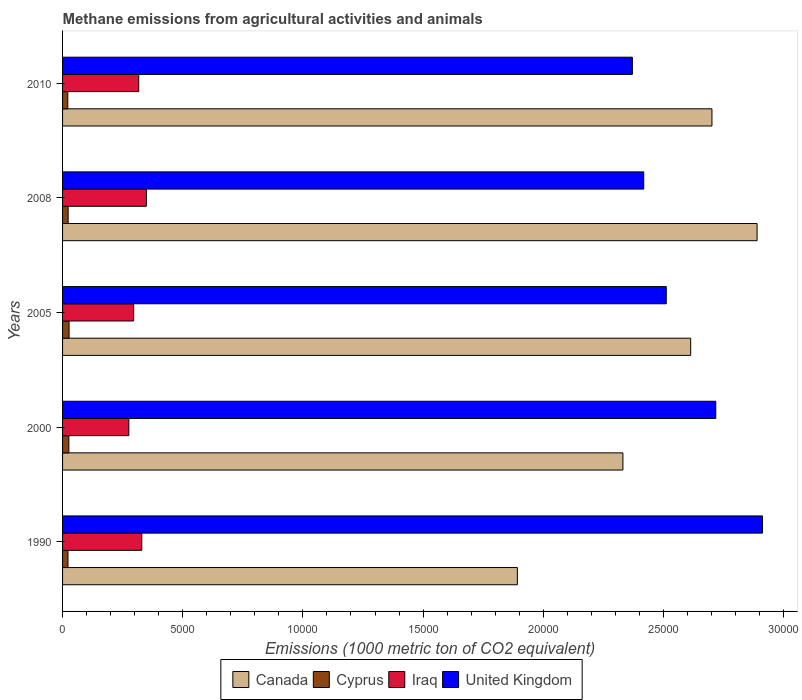How many different coloured bars are there?
Give a very brief answer. 4. How many bars are there on the 3rd tick from the top?
Give a very brief answer. 4. What is the label of the 4th group of bars from the top?
Offer a terse response. 2000. In how many cases, is the number of bars for a given year not equal to the number of legend labels?
Provide a short and direct response. 0. What is the amount of methane emitted in Canada in 2000?
Give a very brief answer. 2.33e+04. Across all years, what is the maximum amount of methane emitted in Iraq?
Your answer should be compact. 3487.5. Across all years, what is the minimum amount of methane emitted in United Kingdom?
Your answer should be compact. 2.37e+04. In which year was the amount of methane emitted in United Kingdom maximum?
Give a very brief answer. 1990. What is the total amount of methane emitted in Canada in the graph?
Offer a very short reply. 1.24e+05. What is the difference between the amount of methane emitted in Cyprus in 2000 and that in 2010?
Your answer should be very brief. 44.1. What is the difference between the amount of methane emitted in United Kingdom in 1990 and the amount of methane emitted in Cyprus in 2010?
Your answer should be very brief. 2.89e+04. What is the average amount of methane emitted in Cyprus per year?
Keep it short and to the point. 241.42. In the year 2005, what is the difference between the amount of methane emitted in Iraq and amount of methane emitted in United Kingdom?
Your response must be concise. -2.22e+04. In how many years, is the amount of methane emitted in Iraq greater than 15000 1000 metric ton?
Keep it short and to the point. 0. What is the ratio of the amount of methane emitted in Cyprus in 1990 to that in 2000?
Your answer should be very brief. 0.86. Is the amount of methane emitted in United Kingdom in 1990 less than that in 2008?
Ensure brevity in your answer.  No. Is the difference between the amount of methane emitted in Iraq in 1990 and 2010 greater than the difference between the amount of methane emitted in United Kingdom in 1990 and 2010?
Keep it short and to the point. No. What is the difference between the highest and the second highest amount of methane emitted in United Kingdom?
Your answer should be compact. 1944.1. What is the difference between the highest and the lowest amount of methane emitted in Iraq?
Keep it short and to the point. 731.3. Is it the case that in every year, the sum of the amount of methane emitted in Cyprus and amount of methane emitted in Canada is greater than the sum of amount of methane emitted in United Kingdom and amount of methane emitted in Iraq?
Keep it short and to the point. No. What does the 3rd bar from the bottom in 2010 represents?
Keep it short and to the point. Iraq. Are all the bars in the graph horizontal?
Ensure brevity in your answer.  Yes. How many years are there in the graph?
Give a very brief answer. 5. What is the difference between two consecutive major ticks on the X-axis?
Your answer should be very brief. 5000. Are the values on the major ticks of X-axis written in scientific E-notation?
Your answer should be compact. No. Does the graph contain any zero values?
Provide a succinct answer. No. Does the graph contain grids?
Keep it short and to the point. No. How many legend labels are there?
Offer a very short reply. 4. What is the title of the graph?
Keep it short and to the point. Methane emissions from agricultural activities and animals. What is the label or title of the X-axis?
Make the answer very short. Emissions (1000 metric ton of CO2 equivalent). What is the label or title of the Y-axis?
Your answer should be very brief. Years. What is the Emissions (1000 metric ton of CO2 equivalent) in Canada in 1990?
Provide a short and direct response. 1.89e+04. What is the Emissions (1000 metric ton of CO2 equivalent) in Cyprus in 1990?
Keep it short and to the point. 225.1. What is the Emissions (1000 metric ton of CO2 equivalent) in Iraq in 1990?
Ensure brevity in your answer.  3295.9. What is the Emissions (1000 metric ton of CO2 equivalent) in United Kingdom in 1990?
Make the answer very short. 2.91e+04. What is the Emissions (1000 metric ton of CO2 equivalent) of Canada in 2000?
Offer a terse response. 2.33e+04. What is the Emissions (1000 metric ton of CO2 equivalent) of Cyprus in 2000?
Provide a short and direct response. 261.7. What is the Emissions (1000 metric ton of CO2 equivalent) of Iraq in 2000?
Give a very brief answer. 2756.2. What is the Emissions (1000 metric ton of CO2 equivalent) of United Kingdom in 2000?
Provide a short and direct response. 2.72e+04. What is the Emissions (1000 metric ton of CO2 equivalent) in Canada in 2005?
Offer a very short reply. 2.61e+04. What is the Emissions (1000 metric ton of CO2 equivalent) of Cyprus in 2005?
Provide a short and direct response. 271. What is the Emissions (1000 metric ton of CO2 equivalent) of Iraq in 2005?
Provide a succinct answer. 2958.3. What is the Emissions (1000 metric ton of CO2 equivalent) of United Kingdom in 2005?
Offer a terse response. 2.51e+04. What is the Emissions (1000 metric ton of CO2 equivalent) in Canada in 2008?
Offer a terse response. 2.89e+04. What is the Emissions (1000 metric ton of CO2 equivalent) in Cyprus in 2008?
Offer a very short reply. 231.7. What is the Emissions (1000 metric ton of CO2 equivalent) of Iraq in 2008?
Provide a succinct answer. 3487.5. What is the Emissions (1000 metric ton of CO2 equivalent) in United Kingdom in 2008?
Give a very brief answer. 2.42e+04. What is the Emissions (1000 metric ton of CO2 equivalent) of Canada in 2010?
Offer a terse response. 2.70e+04. What is the Emissions (1000 metric ton of CO2 equivalent) of Cyprus in 2010?
Ensure brevity in your answer.  217.6. What is the Emissions (1000 metric ton of CO2 equivalent) of Iraq in 2010?
Provide a short and direct response. 3168.9. What is the Emissions (1000 metric ton of CO2 equivalent) of United Kingdom in 2010?
Ensure brevity in your answer.  2.37e+04. Across all years, what is the maximum Emissions (1000 metric ton of CO2 equivalent) in Canada?
Provide a short and direct response. 2.89e+04. Across all years, what is the maximum Emissions (1000 metric ton of CO2 equivalent) of Cyprus?
Your response must be concise. 271. Across all years, what is the maximum Emissions (1000 metric ton of CO2 equivalent) of Iraq?
Provide a succinct answer. 3487.5. Across all years, what is the maximum Emissions (1000 metric ton of CO2 equivalent) of United Kingdom?
Keep it short and to the point. 2.91e+04. Across all years, what is the minimum Emissions (1000 metric ton of CO2 equivalent) of Canada?
Offer a very short reply. 1.89e+04. Across all years, what is the minimum Emissions (1000 metric ton of CO2 equivalent) of Cyprus?
Your answer should be very brief. 217.6. Across all years, what is the minimum Emissions (1000 metric ton of CO2 equivalent) in Iraq?
Your response must be concise. 2756.2. Across all years, what is the minimum Emissions (1000 metric ton of CO2 equivalent) in United Kingdom?
Offer a terse response. 2.37e+04. What is the total Emissions (1000 metric ton of CO2 equivalent) in Canada in the graph?
Give a very brief answer. 1.24e+05. What is the total Emissions (1000 metric ton of CO2 equivalent) in Cyprus in the graph?
Your response must be concise. 1207.1. What is the total Emissions (1000 metric ton of CO2 equivalent) of Iraq in the graph?
Your answer should be very brief. 1.57e+04. What is the total Emissions (1000 metric ton of CO2 equivalent) in United Kingdom in the graph?
Offer a terse response. 1.29e+05. What is the difference between the Emissions (1000 metric ton of CO2 equivalent) of Canada in 1990 and that in 2000?
Ensure brevity in your answer.  -4391.7. What is the difference between the Emissions (1000 metric ton of CO2 equivalent) of Cyprus in 1990 and that in 2000?
Offer a terse response. -36.6. What is the difference between the Emissions (1000 metric ton of CO2 equivalent) of Iraq in 1990 and that in 2000?
Your answer should be very brief. 539.7. What is the difference between the Emissions (1000 metric ton of CO2 equivalent) of United Kingdom in 1990 and that in 2000?
Offer a terse response. 1944.1. What is the difference between the Emissions (1000 metric ton of CO2 equivalent) in Canada in 1990 and that in 2005?
Your answer should be very brief. -7210.8. What is the difference between the Emissions (1000 metric ton of CO2 equivalent) in Cyprus in 1990 and that in 2005?
Give a very brief answer. -45.9. What is the difference between the Emissions (1000 metric ton of CO2 equivalent) of Iraq in 1990 and that in 2005?
Make the answer very short. 337.6. What is the difference between the Emissions (1000 metric ton of CO2 equivalent) of United Kingdom in 1990 and that in 2005?
Provide a succinct answer. 4004.1. What is the difference between the Emissions (1000 metric ton of CO2 equivalent) of Canada in 1990 and that in 2008?
Your answer should be very brief. -9973.1. What is the difference between the Emissions (1000 metric ton of CO2 equivalent) of Iraq in 1990 and that in 2008?
Your answer should be compact. -191.6. What is the difference between the Emissions (1000 metric ton of CO2 equivalent) in United Kingdom in 1990 and that in 2008?
Provide a succinct answer. 4941.2. What is the difference between the Emissions (1000 metric ton of CO2 equivalent) of Canada in 1990 and that in 2010?
Offer a terse response. -8095.8. What is the difference between the Emissions (1000 metric ton of CO2 equivalent) in Cyprus in 1990 and that in 2010?
Your answer should be compact. 7.5. What is the difference between the Emissions (1000 metric ton of CO2 equivalent) in Iraq in 1990 and that in 2010?
Provide a short and direct response. 127. What is the difference between the Emissions (1000 metric ton of CO2 equivalent) of United Kingdom in 1990 and that in 2010?
Your response must be concise. 5414.5. What is the difference between the Emissions (1000 metric ton of CO2 equivalent) in Canada in 2000 and that in 2005?
Ensure brevity in your answer.  -2819.1. What is the difference between the Emissions (1000 metric ton of CO2 equivalent) of Cyprus in 2000 and that in 2005?
Your answer should be compact. -9.3. What is the difference between the Emissions (1000 metric ton of CO2 equivalent) of Iraq in 2000 and that in 2005?
Your response must be concise. -202.1. What is the difference between the Emissions (1000 metric ton of CO2 equivalent) in United Kingdom in 2000 and that in 2005?
Provide a succinct answer. 2060. What is the difference between the Emissions (1000 metric ton of CO2 equivalent) of Canada in 2000 and that in 2008?
Provide a succinct answer. -5581.4. What is the difference between the Emissions (1000 metric ton of CO2 equivalent) of Cyprus in 2000 and that in 2008?
Make the answer very short. 30. What is the difference between the Emissions (1000 metric ton of CO2 equivalent) of Iraq in 2000 and that in 2008?
Give a very brief answer. -731.3. What is the difference between the Emissions (1000 metric ton of CO2 equivalent) of United Kingdom in 2000 and that in 2008?
Ensure brevity in your answer.  2997.1. What is the difference between the Emissions (1000 metric ton of CO2 equivalent) of Canada in 2000 and that in 2010?
Ensure brevity in your answer.  -3704.1. What is the difference between the Emissions (1000 metric ton of CO2 equivalent) in Cyprus in 2000 and that in 2010?
Offer a very short reply. 44.1. What is the difference between the Emissions (1000 metric ton of CO2 equivalent) in Iraq in 2000 and that in 2010?
Provide a short and direct response. -412.7. What is the difference between the Emissions (1000 metric ton of CO2 equivalent) in United Kingdom in 2000 and that in 2010?
Keep it short and to the point. 3470.4. What is the difference between the Emissions (1000 metric ton of CO2 equivalent) in Canada in 2005 and that in 2008?
Give a very brief answer. -2762.3. What is the difference between the Emissions (1000 metric ton of CO2 equivalent) in Cyprus in 2005 and that in 2008?
Ensure brevity in your answer.  39.3. What is the difference between the Emissions (1000 metric ton of CO2 equivalent) in Iraq in 2005 and that in 2008?
Give a very brief answer. -529.2. What is the difference between the Emissions (1000 metric ton of CO2 equivalent) in United Kingdom in 2005 and that in 2008?
Make the answer very short. 937.1. What is the difference between the Emissions (1000 metric ton of CO2 equivalent) of Canada in 2005 and that in 2010?
Ensure brevity in your answer.  -885. What is the difference between the Emissions (1000 metric ton of CO2 equivalent) of Cyprus in 2005 and that in 2010?
Offer a very short reply. 53.4. What is the difference between the Emissions (1000 metric ton of CO2 equivalent) of Iraq in 2005 and that in 2010?
Keep it short and to the point. -210.6. What is the difference between the Emissions (1000 metric ton of CO2 equivalent) of United Kingdom in 2005 and that in 2010?
Provide a succinct answer. 1410.4. What is the difference between the Emissions (1000 metric ton of CO2 equivalent) in Canada in 2008 and that in 2010?
Offer a very short reply. 1877.3. What is the difference between the Emissions (1000 metric ton of CO2 equivalent) of Cyprus in 2008 and that in 2010?
Your answer should be very brief. 14.1. What is the difference between the Emissions (1000 metric ton of CO2 equivalent) in Iraq in 2008 and that in 2010?
Your answer should be compact. 318.6. What is the difference between the Emissions (1000 metric ton of CO2 equivalent) of United Kingdom in 2008 and that in 2010?
Your response must be concise. 473.3. What is the difference between the Emissions (1000 metric ton of CO2 equivalent) of Canada in 1990 and the Emissions (1000 metric ton of CO2 equivalent) of Cyprus in 2000?
Ensure brevity in your answer.  1.87e+04. What is the difference between the Emissions (1000 metric ton of CO2 equivalent) of Canada in 1990 and the Emissions (1000 metric ton of CO2 equivalent) of Iraq in 2000?
Ensure brevity in your answer.  1.62e+04. What is the difference between the Emissions (1000 metric ton of CO2 equivalent) of Canada in 1990 and the Emissions (1000 metric ton of CO2 equivalent) of United Kingdom in 2000?
Ensure brevity in your answer.  -8254.7. What is the difference between the Emissions (1000 metric ton of CO2 equivalent) in Cyprus in 1990 and the Emissions (1000 metric ton of CO2 equivalent) in Iraq in 2000?
Your response must be concise. -2531.1. What is the difference between the Emissions (1000 metric ton of CO2 equivalent) in Cyprus in 1990 and the Emissions (1000 metric ton of CO2 equivalent) in United Kingdom in 2000?
Provide a succinct answer. -2.70e+04. What is the difference between the Emissions (1000 metric ton of CO2 equivalent) of Iraq in 1990 and the Emissions (1000 metric ton of CO2 equivalent) of United Kingdom in 2000?
Your answer should be very brief. -2.39e+04. What is the difference between the Emissions (1000 metric ton of CO2 equivalent) in Canada in 1990 and the Emissions (1000 metric ton of CO2 equivalent) in Cyprus in 2005?
Provide a succinct answer. 1.87e+04. What is the difference between the Emissions (1000 metric ton of CO2 equivalent) of Canada in 1990 and the Emissions (1000 metric ton of CO2 equivalent) of Iraq in 2005?
Offer a very short reply. 1.60e+04. What is the difference between the Emissions (1000 metric ton of CO2 equivalent) of Canada in 1990 and the Emissions (1000 metric ton of CO2 equivalent) of United Kingdom in 2005?
Keep it short and to the point. -6194.7. What is the difference between the Emissions (1000 metric ton of CO2 equivalent) of Cyprus in 1990 and the Emissions (1000 metric ton of CO2 equivalent) of Iraq in 2005?
Provide a short and direct response. -2733.2. What is the difference between the Emissions (1000 metric ton of CO2 equivalent) of Cyprus in 1990 and the Emissions (1000 metric ton of CO2 equivalent) of United Kingdom in 2005?
Offer a terse response. -2.49e+04. What is the difference between the Emissions (1000 metric ton of CO2 equivalent) of Iraq in 1990 and the Emissions (1000 metric ton of CO2 equivalent) of United Kingdom in 2005?
Keep it short and to the point. -2.18e+04. What is the difference between the Emissions (1000 metric ton of CO2 equivalent) in Canada in 1990 and the Emissions (1000 metric ton of CO2 equivalent) in Cyprus in 2008?
Ensure brevity in your answer.  1.87e+04. What is the difference between the Emissions (1000 metric ton of CO2 equivalent) of Canada in 1990 and the Emissions (1000 metric ton of CO2 equivalent) of Iraq in 2008?
Offer a terse response. 1.54e+04. What is the difference between the Emissions (1000 metric ton of CO2 equivalent) in Canada in 1990 and the Emissions (1000 metric ton of CO2 equivalent) in United Kingdom in 2008?
Offer a terse response. -5257.6. What is the difference between the Emissions (1000 metric ton of CO2 equivalent) of Cyprus in 1990 and the Emissions (1000 metric ton of CO2 equivalent) of Iraq in 2008?
Your response must be concise. -3262.4. What is the difference between the Emissions (1000 metric ton of CO2 equivalent) in Cyprus in 1990 and the Emissions (1000 metric ton of CO2 equivalent) in United Kingdom in 2008?
Your answer should be very brief. -2.40e+04. What is the difference between the Emissions (1000 metric ton of CO2 equivalent) of Iraq in 1990 and the Emissions (1000 metric ton of CO2 equivalent) of United Kingdom in 2008?
Give a very brief answer. -2.09e+04. What is the difference between the Emissions (1000 metric ton of CO2 equivalent) of Canada in 1990 and the Emissions (1000 metric ton of CO2 equivalent) of Cyprus in 2010?
Your answer should be compact. 1.87e+04. What is the difference between the Emissions (1000 metric ton of CO2 equivalent) in Canada in 1990 and the Emissions (1000 metric ton of CO2 equivalent) in Iraq in 2010?
Your answer should be compact. 1.58e+04. What is the difference between the Emissions (1000 metric ton of CO2 equivalent) in Canada in 1990 and the Emissions (1000 metric ton of CO2 equivalent) in United Kingdom in 2010?
Provide a succinct answer. -4784.3. What is the difference between the Emissions (1000 metric ton of CO2 equivalent) in Cyprus in 1990 and the Emissions (1000 metric ton of CO2 equivalent) in Iraq in 2010?
Provide a short and direct response. -2943.8. What is the difference between the Emissions (1000 metric ton of CO2 equivalent) in Cyprus in 1990 and the Emissions (1000 metric ton of CO2 equivalent) in United Kingdom in 2010?
Your answer should be very brief. -2.35e+04. What is the difference between the Emissions (1000 metric ton of CO2 equivalent) in Iraq in 1990 and the Emissions (1000 metric ton of CO2 equivalent) in United Kingdom in 2010?
Give a very brief answer. -2.04e+04. What is the difference between the Emissions (1000 metric ton of CO2 equivalent) in Canada in 2000 and the Emissions (1000 metric ton of CO2 equivalent) in Cyprus in 2005?
Ensure brevity in your answer.  2.30e+04. What is the difference between the Emissions (1000 metric ton of CO2 equivalent) in Canada in 2000 and the Emissions (1000 metric ton of CO2 equivalent) in Iraq in 2005?
Give a very brief answer. 2.04e+04. What is the difference between the Emissions (1000 metric ton of CO2 equivalent) in Canada in 2000 and the Emissions (1000 metric ton of CO2 equivalent) in United Kingdom in 2005?
Ensure brevity in your answer.  -1803. What is the difference between the Emissions (1000 metric ton of CO2 equivalent) in Cyprus in 2000 and the Emissions (1000 metric ton of CO2 equivalent) in Iraq in 2005?
Keep it short and to the point. -2696.6. What is the difference between the Emissions (1000 metric ton of CO2 equivalent) of Cyprus in 2000 and the Emissions (1000 metric ton of CO2 equivalent) of United Kingdom in 2005?
Provide a succinct answer. -2.49e+04. What is the difference between the Emissions (1000 metric ton of CO2 equivalent) in Iraq in 2000 and the Emissions (1000 metric ton of CO2 equivalent) in United Kingdom in 2005?
Offer a very short reply. -2.24e+04. What is the difference between the Emissions (1000 metric ton of CO2 equivalent) in Canada in 2000 and the Emissions (1000 metric ton of CO2 equivalent) in Cyprus in 2008?
Ensure brevity in your answer.  2.31e+04. What is the difference between the Emissions (1000 metric ton of CO2 equivalent) of Canada in 2000 and the Emissions (1000 metric ton of CO2 equivalent) of Iraq in 2008?
Offer a very short reply. 1.98e+04. What is the difference between the Emissions (1000 metric ton of CO2 equivalent) of Canada in 2000 and the Emissions (1000 metric ton of CO2 equivalent) of United Kingdom in 2008?
Make the answer very short. -865.9. What is the difference between the Emissions (1000 metric ton of CO2 equivalent) in Cyprus in 2000 and the Emissions (1000 metric ton of CO2 equivalent) in Iraq in 2008?
Your answer should be very brief. -3225.8. What is the difference between the Emissions (1000 metric ton of CO2 equivalent) in Cyprus in 2000 and the Emissions (1000 metric ton of CO2 equivalent) in United Kingdom in 2008?
Your answer should be compact. -2.39e+04. What is the difference between the Emissions (1000 metric ton of CO2 equivalent) of Iraq in 2000 and the Emissions (1000 metric ton of CO2 equivalent) of United Kingdom in 2008?
Ensure brevity in your answer.  -2.14e+04. What is the difference between the Emissions (1000 metric ton of CO2 equivalent) of Canada in 2000 and the Emissions (1000 metric ton of CO2 equivalent) of Cyprus in 2010?
Keep it short and to the point. 2.31e+04. What is the difference between the Emissions (1000 metric ton of CO2 equivalent) in Canada in 2000 and the Emissions (1000 metric ton of CO2 equivalent) in Iraq in 2010?
Provide a short and direct response. 2.01e+04. What is the difference between the Emissions (1000 metric ton of CO2 equivalent) of Canada in 2000 and the Emissions (1000 metric ton of CO2 equivalent) of United Kingdom in 2010?
Ensure brevity in your answer.  -392.6. What is the difference between the Emissions (1000 metric ton of CO2 equivalent) in Cyprus in 2000 and the Emissions (1000 metric ton of CO2 equivalent) in Iraq in 2010?
Make the answer very short. -2907.2. What is the difference between the Emissions (1000 metric ton of CO2 equivalent) of Cyprus in 2000 and the Emissions (1000 metric ton of CO2 equivalent) of United Kingdom in 2010?
Ensure brevity in your answer.  -2.34e+04. What is the difference between the Emissions (1000 metric ton of CO2 equivalent) in Iraq in 2000 and the Emissions (1000 metric ton of CO2 equivalent) in United Kingdom in 2010?
Provide a short and direct response. -2.10e+04. What is the difference between the Emissions (1000 metric ton of CO2 equivalent) of Canada in 2005 and the Emissions (1000 metric ton of CO2 equivalent) of Cyprus in 2008?
Your answer should be very brief. 2.59e+04. What is the difference between the Emissions (1000 metric ton of CO2 equivalent) in Canada in 2005 and the Emissions (1000 metric ton of CO2 equivalent) in Iraq in 2008?
Keep it short and to the point. 2.26e+04. What is the difference between the Emissions (1000 metric ton of CO2 equivalent) of Canada in 2005 and the Emissions (1000 metric ton of CO2 equivalent) of United Kingdom in 2008?
Give a very brief answer. 1953.2. What is the difference between the Emissions (1000 metric ton of CO2 equivalent) of Cyprus in 2005 and the Emissions (1000 metric ton of CO2 equivalent) of Iraq in 2008?
Give a very brief answer. -3216.5. What is the difference between the Emissions (1000 metric ton of CO2 equivalent) of Cyprus in 2005 and the Emissions (1000 metric ton of CO2 equivalent) of United Kingdom in 2008?
Keep it short and to the point. -2.39e+04. What is the difference between the Emissions (1000 metric ton of CO2 equivalent) in Iraq in 2005 and the Emissions (1000 metric ton of CO2 equivalent) in United Kingdom in 2008?
Your answer should be very brief. -2.12e+04. What is the difference between the Emissions (1000 metric ton of CO2 equivalent) of Canada in 2005 and the Emissions (1000 metric ton of CO2 equivalent) of Cyprus in 2010?
Provide a short and direct response. 2.59e+04. What is the difference between the Emissions (1000 metric ton of CO2 equivalent) of Canada in 2005 and the Emissions (1000 metric ton of CO2 equivalent) of Iraq in 2010?
Your answer should be very brief. 2.30e+04. What is the difference between the Emissions (1000 metric ton of CO2 equivalent) of Canada in 2005 and the Emissions (1000 metric ton of CO2 equivalent) of United Kingdom in 2010?
Ensure brevity in your answer.  2426.5. What is the difference between the Emissions (1000 metric ton of CO2 equivalent) in Cyprus in 2005 and the Emissions (1000 metric ton of CO2 equivalent) in Iraq in 2010?
Your answer should be compact. -2897.9. What is the difference between the Emissions (1000 metric ton of CO2 equivalent) of Cyprus in 2005 and the Emissions (1000 metric ton of CO2 equivalent) of United Kingdom in 2010?
Ensure brevity in your answer.  -2.34e+04. What is the difference between the Emissions (1000 metric ton of CO2 equivalent) of Iraq in 2005 and the Emissions (1000 metric ton of CO2 equivalent) of United Kingdom in 2010?
Provide a succinct answer. -2.07e+04. What is the difference between the Emissions (1000 metric ton of CO2 equivalent) in Canada in 2008 and the Emissions (1000 metric ton of CO2 equivalent) in Cyprus in 2010?
Ensure brevity in your answer.  2.87e+04. What is the difference between the Emissions (1000 metric ton of CO2 equivalent) of Canada in 2008 and the Emissions (1000 metric ton of CO2 equivalent) of Iraq in 2010?
Provide a short and direct response. 2.57e+04. What is the difference between the Emissions (1000 metric ton of CO2 equivalent) in Canada in 2008 and the Emissions (1000 metric ton of CO2 equivalent) in United Kingdom in 2010?
Offer a terse response. 5188.8. What is the difference between the Emissions (1000 metric ton of CO2 equivalent) in Cyprus in 2008 and the Emissions (1000 metric ton of CO2 equivalent) in Iraq in 2010?
Your answer should be compact. -2937.2. What is the difference between the Emissions (1000 metric ton of CO2 equivalent) of Cyprus in 2008 and the Emissions (1000 metric ton of CO2 equivalent) of United Kingdom in 2010?
Provide a short and direct response. -2.35e+04. What is the difference between the Emissions (1000 metric ton of CO2 equivalent) in Iraq in 2008 and the Emissions (1000 metric ton of CO2 equivalent) in United Kingdom in 2010?
Your answer should be very brief. -2.02e+04. What is the average Emissions (1000 metric ton of CO2 equivalent) in Canada per year?
Your response must be concise. 2.49e+04. What is the average Emissions (1000 metric ton of CO2 equivalent) of Cyprus per year?
Give a very brief answer. 241.42. What is the average Emissions (1000 metric ton of CO2 equivalent) of Iraq per year?
Your answer should be compact. 3133.36. What is the average Emissions (1000 metric ton of CO2 equivalent) of United Kingdom per year?
Ensure brevity in your answer.  2.59e+04. In the year 1990, what is the difference between the Emissions (1000 metric ton of CO2 equivalent) of Canada and Emissions (1000 metric ton of CO2 equivalent) of Cyprus?
Provide a succinct answer. 1.87e+04. In the year 1990, what is the difference between the Emissions (1000 metric ton of CO2 equivalent) in Canada and Emissions (1000 metric ton of CO2 equivalent) in Iraq?
Ensure brevity in your answer.  1.56e+04. In the year 1990, what is the difference between the Emissions (1000 metric ton of CO2 equivalent) of Canada and Emissions (1000 metric ton of CO2 equivalent) of United Kingdom?
Provide a short and direct response. -1.02e+04. In the year 1990, what is the difference between the Emissions (1000 metric ton of CO2 equivalent) of Cyprus and Emissions (1000 metric ton of CO2 equivalent) of Iraq?
Your response must be concise. -3070.8. In the year 1990, what is the difference between the Emissions (1000 metric ton of CO2 equivalent) in Cyprus and Emissions (1000 metric ton of CO2 equivalent) in United Kingdom?
Offer a terse response. -2.89e+04. In the year 1990, what is the difference between the Emissions (1000 metric ton of CO2 equivalent) in Iraq and Emissions (1000 metric ton of CO2 equivalent) in United Kingdom?
Provide a short and direct response. -2.58e+04. In the year 2000, what is the difference between the Emissions (1000 metric ton of CO2 equivalent) of Canada and Emissions (1000 metric ton of CO2 equivalent) of Cyprus?
Your answer should be compact. 2.31e+04. In the year 2000, what is the difference between the Emissions (1000 metric ton of CO2 equivalent) in Canada and Emissions (1000 metric ton of CO2 equivalent) in Iraq?
Make the answer very short. 2.06e+04. In the year 2000, what is the difference between the Emissions (1000 metric ton of CO2 equivalent) in Canada and Emissions (1000 metric ton of CO2 equivalent) in United Kingdom?
Offer a terse response. -3863. In the year 2000, what is the difference between the Emissions (1000 metric ton of CO2 equivalent) in Cyprus and Emissions (1000 metric ton of CO2 equivalent) in Iraq?
Give a very brief answer. -2494.5. In the year 2000, what is the difference between the Emissions (1000 metric ton of CO2 equivalent) in Cyprus and Emissions (1000 metric ton of CO2 equivalent) in United Kingdom?
Offer a terse response. -2.69e+04. In the year 2000, what is the difference between the Emissions (1000 metric ton of CO2 equivalent) of Iraq and Emissions (1000 metric ton of CO2 equivalent) of United Kingdom?
Your answer should be compact. -2.44e+04. In the year 2005, what is the difference between the Emissions (1000 metric ton of CO2 equivalent) in Canada and Emissions (1000 metric ton of CO2 equivalent) in Cyprus?
Keep it short and to the point. 2.59e+04. In the year 2005, what is the difference between the Emissions (1000 metric ton of CO2 equivalent) in Canada and Emissions (1000 metric ton of CO2 equivalent) in Iraq?
Offer a terse response. 2.32e+04. In the year 2005, what is the difference between the Emissions (1000 metric ton of CO2 equivalent) in Canada and Emissions (1000 metric ton of CO2 equivalent) in United Kingdom?
Keep it short and to the point. 1016.1. In the year 2005, what is the difference between the Emissions (1000 metric ton of CO2 equivalent) in Cyprus and Emissions (1000 metric ton of CO2 equivalent) in Iraq?
Your answer should be very brief. -2687.3. In the year 2005, what is the difference between the Emissions (1000 metric ton of CO2 equivalent) of Cyprus and Emissions (1000 metric ton of CO2 equivalent) of United Kingdom?
Your response must be concise. -2.48e+04. In the year 2005, what is the difference between the Emissions (1000 metric ton of CO2 equivalent) of Iraq and Emissions (1000 metric ton of CO2 equivalent) of United Kingdom?
Your answer should be compact. -2.22e+04. In the year 2008, what is the difference between the Emissions (1000 metric ton of CO2 equivalent) in Canada and Emissions (1000 metric ton of CO2 equivalent) in Cyprus?
Make the answer very short. 2.87e+04. In the year 2008, what is the difference between the Emissions (1000 metric ton of CO2 equivalent) in Canada and Emissions (1000 metric ton of CO2 equivalent) in Iraq?
Your answer should be very brief. 2.54e+04. In the year 2008, what is the difference between the Emissions (1000 metric ton of CO2 equivalent) in Canada and Emissions (1000 metric ton of CO2 equivalent) in United Kingdom?
Offer a very short reply. 4715.5. In the year 2008, what is the difference between the Emissions (1000 metric ton of CO2 equivalent) in Cyprus and Emissions (1000 metric ton of CO2 equivalent) in Iraq?
Ensure brevity in your answer.  -3255.8. In the year 2008, what is the difference between the Emissions (1000 metric ton of CO2 equivalent) of Cyprus and Emissions (1000 metric ton of CO2 equivalent) of United Kingdom?
Give a very brief answer. -2.39e+04. In the year 2008, what is the difference between the Emissions (1000 metric ton of CO2 equivalent) in Iraq and Emissions (1000 metric ton of CO2 equivalent) in United Kingdom?
Your answer should be very brief. -2.07e+04. In the year 2010, what is the difference between the Emissions (1000 metric ton of CO2 equivalent) in Canada and Emissions (1000 metric ton of CO2 equivalent) in Cyprus?
Your answer should be very brief. 2.68e+04. In the year 2010, what is the difference between the Emissions (1000 metric ton of CO2 equivalent) in Canada and Emissions (1000 metric ton of CO2 equivalent) in Iraq?
Provide a short and direct response. 2.39e+04. In the year 2010, what is the difference between the Emissions (1000 metric ton of CO2 equivalent) in Canada and Emissions (1000 metric ton of CO2 equivalent) in United Kingdom?
Offer a very short reply. 3311.5. In the year 2010, what is the difference between the Emissions (1000 metric ton of CO2 equivalent) of Cyprus and Emissions (1000 metric ton of CO2 equivalent) of Iraq?
Your answer should be very brief. -2951.3. In the year 2010, what is the difference between the Emissions (1000 metric ton of CO2 equivalent) of Cyprus and Emissions (1000 metric ton of CO2 equivalent) of United Kingdom?
Keep it short and to the point. -2.35e+04. In the year 2010, what is the difference between the Emissions (1000 metric ton of CO2 equivalent) in Iraq and Emissions (1000 metric ton of CO2 equivalent) in United Kingdom?
Your response must be concise. -2.05e+04. What is the ratio of the Emissions (1000 metric ton of CO2 equivalent) in Canada in 1990 to that in 2000?
Give a very brief answer. 0.81. What is the ratio of the Emissions (1000 metric ton of CO2 equivalent) in Cyprus in 1990 to that in 2000?
Your answer should be very brief. 0.86. What is the ratio of the Emissions (1000 metric ton of CO2 equivalent) of Iraq in 1990 to that in 2000?
Keep it short and to the point. 1.2. What is the ratio of the Emissions (1000 metric ton of CO2 equivalent) in United Kingdom in 1990 to that in 2000?
Provide a short and direct response. 1.07. What is the ratio of the Emissions (1000 metric ton of CO2 equivalent) in Canada in 1990 to that in 2005?
Give a very brief answer. 0.72. What is the ratio of the Emissions (1000 metric ton of CO2 equivalent) in Cyprus in 1990 to that in 2005?
Offer a terse response. 0.83. What is the ratio of the Emissions (1000 metric ton of CO2 equivalent) in Iraq in 1990 to that in 2005?
Provide a short and direct response. 1.11. What is the ratio of the Emissions (1000 metric ton of CO2 equivalent) in United Kingdom in 1990 to that in 2005?
Your response must be concise. 1.16. What is the ratio of the Emissions (1000 metric ton of CO2 equivalent) in Canada in 1990 to that in 2008?
Offer a terse response. 0.65. What is the ratio of the Emissions (1000 metric ton of CO2 equivalent) in Cyprus in 1990 to that in 2008?
Provide a succinct answer. 0.97. What is the ratio of the Emissions (1000 metric ton of CO2 equivalent) in Iraq in 1990 to that in 2008?
Make the answer very short. 0.95. What is the ratio of the Emissions (1000 metric ton of CO2 equivalent) of United Kingdom in 1990 to that in 2008?
Your answer should be compact. 1.2. What is the ratio of the Emissions (1000 metric ton of CO2 equivalent) of Canada in 1990 to that in 2010?
Your answer should be very brief. 0.7. What is the ratio of the Emissions (1000 metric ton of CO2 equivalent) in Cyprus in 1990 to that in 2010?
Offer a terse response. 1.03. What is the ratio of the Emissions (1000 metric ton of CO2 equivalent) in Iraq in 1990 to that in 2010?
Keep it short and to the point. 1.04. What is the ratio of the Emissions (1000 metric ton of CO2 equivalent) of United Kingdom in 1990 to that in 2010?
Your answer should be compact. 1.23. What is the ratio of the Emissions (1000 metric ton of CO2 equivalent) of Canada in 2000 to that in 2005?
Give a very brief answer. 0.89. What is the ratio of the Emissions (1000 metric ton of CO2 equivalent) in Cyprus in 2000 to that in 2005?
Your answer should be very brief. 0.97. What is the ratio of the Emissions (1000 metric ton of CO2 equivalent) of Iraq in 2000 to that in 2005?
Your answer should be very brief. 0.93. What is the ratio of the Emissions (1000 metric ton of CO2 equivalent) in United Kingdom in 2000 to that in 2005?
Your response must be concise. 1.08. What is the ratio of the Emissions (1000 metric ton of CO2 equivalent) of Canada in 2000 to that in 2008?
Give a very brief answer. 0.81. What is the ratio of the Emissions (1000 metric ton of CO2 equivalent) of Cyprus in 2000 to that in 2008?
Offer a very short reply. 1.13. What is the ratio of the Emissions (1000 metric ton of CO2 equivalent) of Iraq in 2000 to that in 2008?
Provide a succinct answer. 0.79. What is the ratio of the Emissions (1000 metric ton of CO2 equivalent) of United Kingdom in 2000 to that in 2008?
Make the answer very short. 1.12. What is the ratio of the Emissions (1000 metric ton of CO2 equivalent) in Canada in 2000 to that in 2010?
Keep it short and to the point. 0.86. What is the ratio of the Emissions (1000 metric ton of CO2 equivalent) of Cyprus in 2000 to that in 2010?
Give a very brief answer. 1.2. What is the ratio of the Emissions (1000 metric ton of CO2 equivalent) in Iraq in 2000 to that in 2010?
Your response must be concise. 0.87. What is the ratio of the Emissions (1000 metric ton of CO2 equivalent) in United Kingdom in 2000 to that in 2010?
Keep it short and to the point. 1.15. What is the ratio of the Emissions (1000 metric ton of CO2 equivalent) of Canada in 2005 to that in 2008?
Your response must be concise. 0.9. What is the ratio of the Emissions (1000 metric ton of CO2 equivalent) of Cyprus in 2005 to that in 2008?
Your answer should be compact. 1.17. What is the ratio of the Emissions (1000 metric ton of CO2 equivalent) of Iraq in 2005 to that in 2008?
Offer a terse response. 0.85. What is the ratio of the Emissions (1000 metric ton of CO2 equivalent) of United Kingdom in 2005 to that in 2008?
Offer a terse response. 1.04. What is the ratio of the Emissions (1000 metric ton of CO2 equivalent) in Canada in 2005 to that in 2010?
Provide a succinct answer. 0.97. What is the ratio of the Emissions (1000 metric ton of CO2 equivalent) in Cyprus in 2005 to that in 2010?
Ensure brevity in your answer.  1.25. What is the ratio of the Emissions (1000 metric ton of CO2 equivalent) in Iraq in 2005 to that in 2010?
Provide a succinct answer. 0.93. What is the ratio of the Emissions (1000 metric ton of CO2 equivalent) of United Kingdom in 2005 to that in 2010?
Ensure brevity in your answer.  1.06. What is the ratio of the Emissions (1000 metric ton of CO2 equivalent) of Canada in 2008 to that in 2010?
Keep it short and to the point. 1.07. What is the ratio of the Emissions (1000 metric ton of CO2 equivalent) in Cyprus in 2008 to that in 2010?
Your answer should be compact. 1.06. What is the ratio of the Emissions (1000 metric ton of CO2 equivalent) of Iraq in 2008 to that in 2010?
Offer a terse response. 1.1. What is the ratio of the Emissions (1000 metric ton of CO2 equivalent) of United Kingdom in 2008 to that in 2010?
Offer a terse response. 1.02. What is the difference between the highest and the second highest Emissions (1000 metric ton of CO2 equivalent) in Canada?
Keep it short and to the point. 1877.3. What is the difference between the highest and the second highest Emissions (1000 metric ton of CO2 equivalent) in Iraq?
Give a very brief answer. 191.6. What is the difference between the highest and the second highest Emissions (1000 metric ton of CO2 equivalent) in United Kingdom?
Offer a very short reply. 1944.1. What is the difference between the highest and the lowest Emissions (1000 metric ton of CO2 equivalent) of Canada?
Your response must be concise. 9973.1. What is the difference between the highest and the lowest Emissions (1000 metric ton of CO2 equivalent) of Cyprus?
Your response must be concise. 53.4. What is the difference between the highest and the lowest Emissions (1000 metric ton of CO2 equivalent) in Iraq?
Keep it short and to the point. 731.3. What is the difference between the highest and the lowest Emissions (1000 metric ton of CO2 equivalent) of United Kingdom?
Your answer should be very brief. 5414.5. 